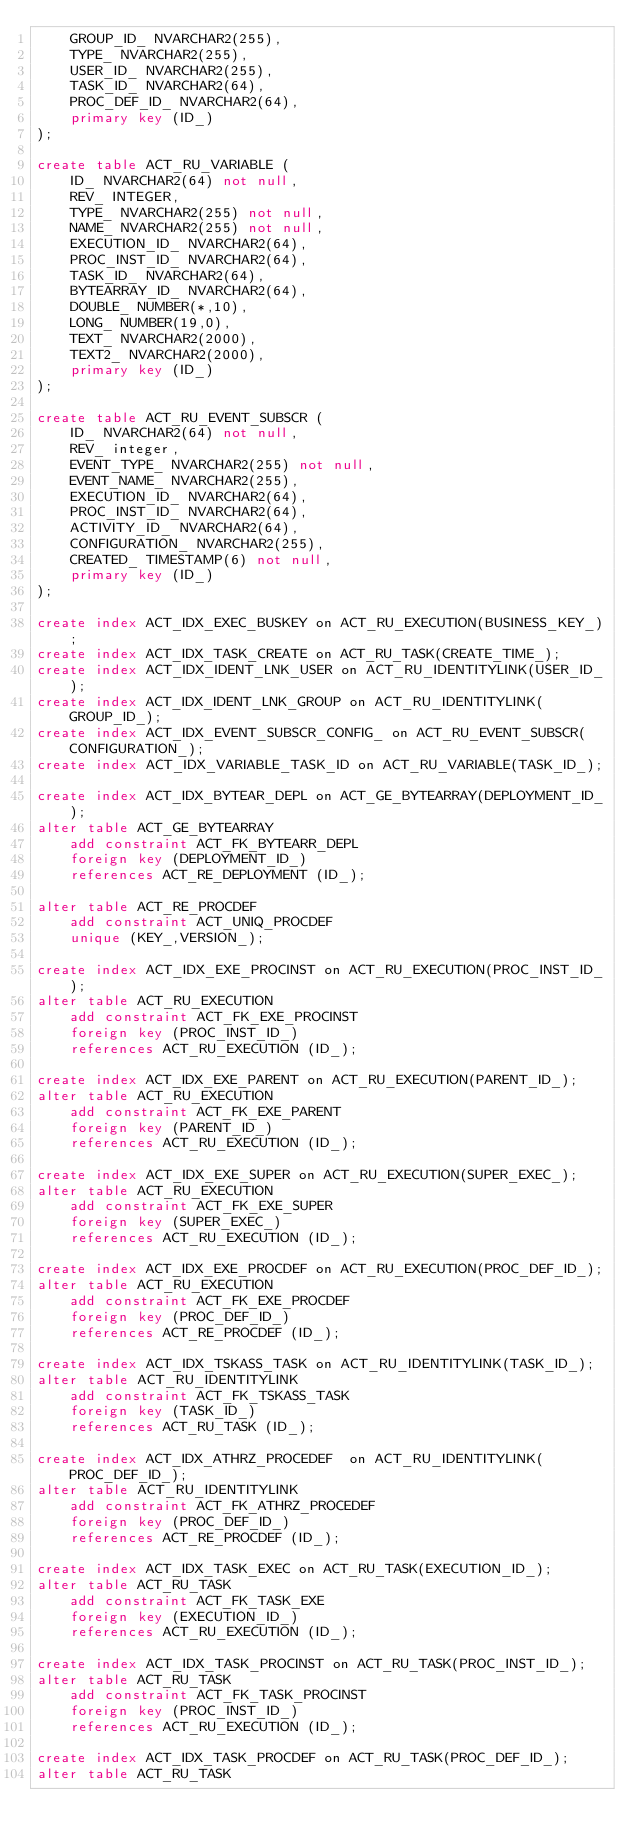<code> <loc_0><loc_0><loc_500><loc_500><_SQL_>    GROUP_ID_ NVARCHAR2(255),
    TYPE_ NVARCHAR2(255),
    USER_ID_ NVARCHAR2(255),
    TASK_ID_ NVARCHAR2(64),
    PROC_DEF_ID_ NVARCHAR2(64),
    primary key (ID_)
);

create table ACT_RU_VARIABLE (
    ID_ NVARCHAR2(64) not null,
    REV_ INTEGER,
    TYPE_ NVARCHAR2(255) not null,
    NAME_ NVARCHAR2(255) not null,
    EXECUTION_ID_ NVARCHAR2(64),
    PROC_INST_ID_ NVARCHAR2(64),
    TASK_ID_ NVARCHAR2(64),
    BYTEARRAY_ID_ NVARCHAR2(64),
    DOUBLE_ NUMBER(*,10),
    LONG_ NUMBER(19,0),
    TEXT_ NVARCHAR2(2000),
    TEXT2_ NVARCHAR2(2000),
    primary key (ID_)
);

create table ACT_RU_EVENT_SUBSCR (
    ID_ NVARCHAR2(64) not null,
    REV_ integer,
    EVENT_TYPE_ NVARCHAR2(255) not null,
    EVENT_NAME_ NVARCHAR2(255),
    EXECUTION_ID_ NVARCHAR2(64),
    PROC_INST_ID_ NVARCHAR2(64),
    ACTIVITY_ID_ NVARCHAR2(64),
    CONFIGURATION_ NVARCHAR2(255),
    CREATED_ TIMESTAMP(6) not null,
    primary key (ID_)
);

create index ACT_IDX_EXEC_BUSKEY on ACT_RU_EXECUTION(BUSINESS_KEY_);
create index ACT_IDX_TASK_CREATE on ACT_RU_TASK(CREATE_TIME_);
create index ACT_IDX_IDENT_LNK_USER on ACT_RU_IDENTITYLINK(USER_ID_);
create index ACT_IDX_IDENT_LNK_GROUP on ACT_RU_IDENTITYLINK(GROUP_ID_);
create index ACT_IDX_EVENT_SUBSCR_CONFIG_ on ACT_RU_EVENT_SUBSCR(CONFIGURATION_);
create index ACT_IDX_VARIABLE_TASK_ID on ACT_RU_VARIABLE(TASK_ID_);

create index ACT_IDX_BYTEAR_DEPL on ACT_GE_BYTEARRAY(DEPLOYMENT_ID_);
alter table ACT_GE_BYTEARRAY
    add constraint ACT_FK_BYTEARR_DEPL
    foreign key (DEPLOYMENT_ID_) 
    references ACT_RE_DEPLOYMENT (ID_);

alter table ACT_RE_PROCDEF
    add constraint ACT_UNIQ_PROCDEF
    unique (KEY_,VERSION_);
    
create index ACT_IDX_EXE_PROCINST on ACT_RU_EXECUTION(PROC_INST_ID_);
alter table ACT_RU_EXECUTION
    add constraint ACT_FK_EXE_PROCINST
    foreign key (PROC_INST_ID_) 
    references ACT_RU_EXECUTION (ID_);

create index ACT_IDX_EXE_PARENT on ACT_RU_EXECUTION(PARENT_ID_);
alter table ACT_RU_EXECUTION
    add constraint ACT_FK_EXE_PARENT
    foreign key (PARENT_ID_) 
    references ACT_RU_EXECUTION (ID_);
    
create index ACT_IDX_EXE_SUPER on ACT_RU_EXECUTION(SUPER_EXEC_);
alter table ACT_RU_EXECUTION
    add constraint ACT_FK_EXE_SUPER
    foreign key (SUPER_EXEC_) 
    references ACT_RU_EXECUTION (ID_);
    
create index ACT_IDX_EXE_PROCDEF on ACT_RU_EXECUTION(PROC_DEF_ID_);
alter table ACT_RU_EXECUTION
    add constraint ACT_FK_EXE_PROCDEF 
    foreign key (PROC_DEF_ID_) 
    references ACT_RE_PROCDEF (ID_);    

create index ACT_IDX_TSKASS_TASK on ACT_RU_IDENTITYLINK(TASK_ID_);
alter table ACT_RU_IDENTITYLINK
    add constraint ACT_FK_TSKASS_TASK
    foreign key (TASK_ID_) 
    references ACT_RU_TASK (ID_);

create index ACT_IDX_ATHRZ_PROCEDEF  on ACT_RU_IDENTITYLINK(PROC_DEF_ID_);
alter table ACT_RU_IDENTITYLINK
    add constraint ACT_FK_ATHRZ_PROCEDEF
    foreign key (PROC_DEF_ID_) 
    references ACT_RE_PROCDEF (ID_);

create index ACT_IDX_TASK_EXEC on ACT_RU_TASK(EXECUTION_ID_);
alter table ACT_RU_TASK
    add constraint ACT_FK_TASK_EXE
    foreign key (EXECUTION_ID_)
    references ACT_RU_EXECUTION (ID_);
    
create index ACT_IDX_TASK_PROCINST on ACT_RU_TASK(PROC_INST_ID_);
alter table ACT_RU_TASK
    add constraint ACT_FK_TASK_PROCINST
    foreign key (PROC_INST_ID_)
    references ACT_RU_EXECUTION (ID_);
    
create index ACT_IDX_TASK_PROCDEF on ACT_RU_TASK(PROC_DEF_ID_);
alter table ACT_RU_TASK</code> 